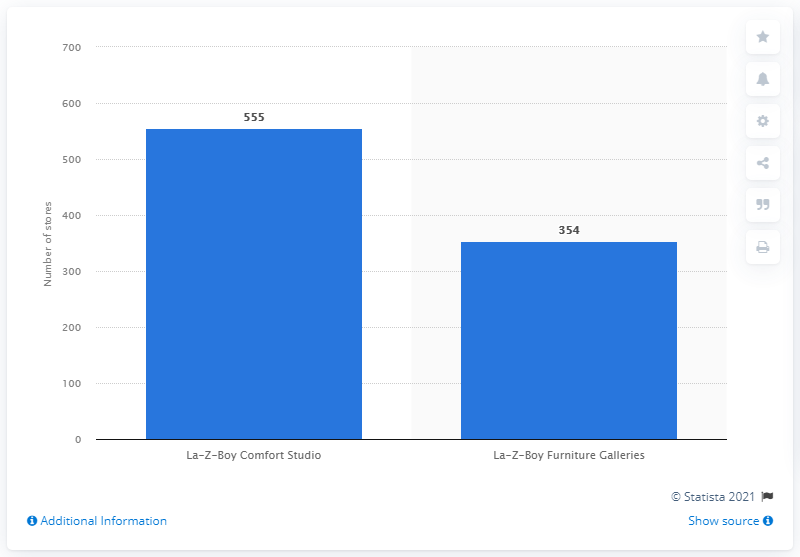List a handful of essential elements in this visual. As of 2020, La-Z-Boy operated 555 locations in its Comfort Studio concept. 